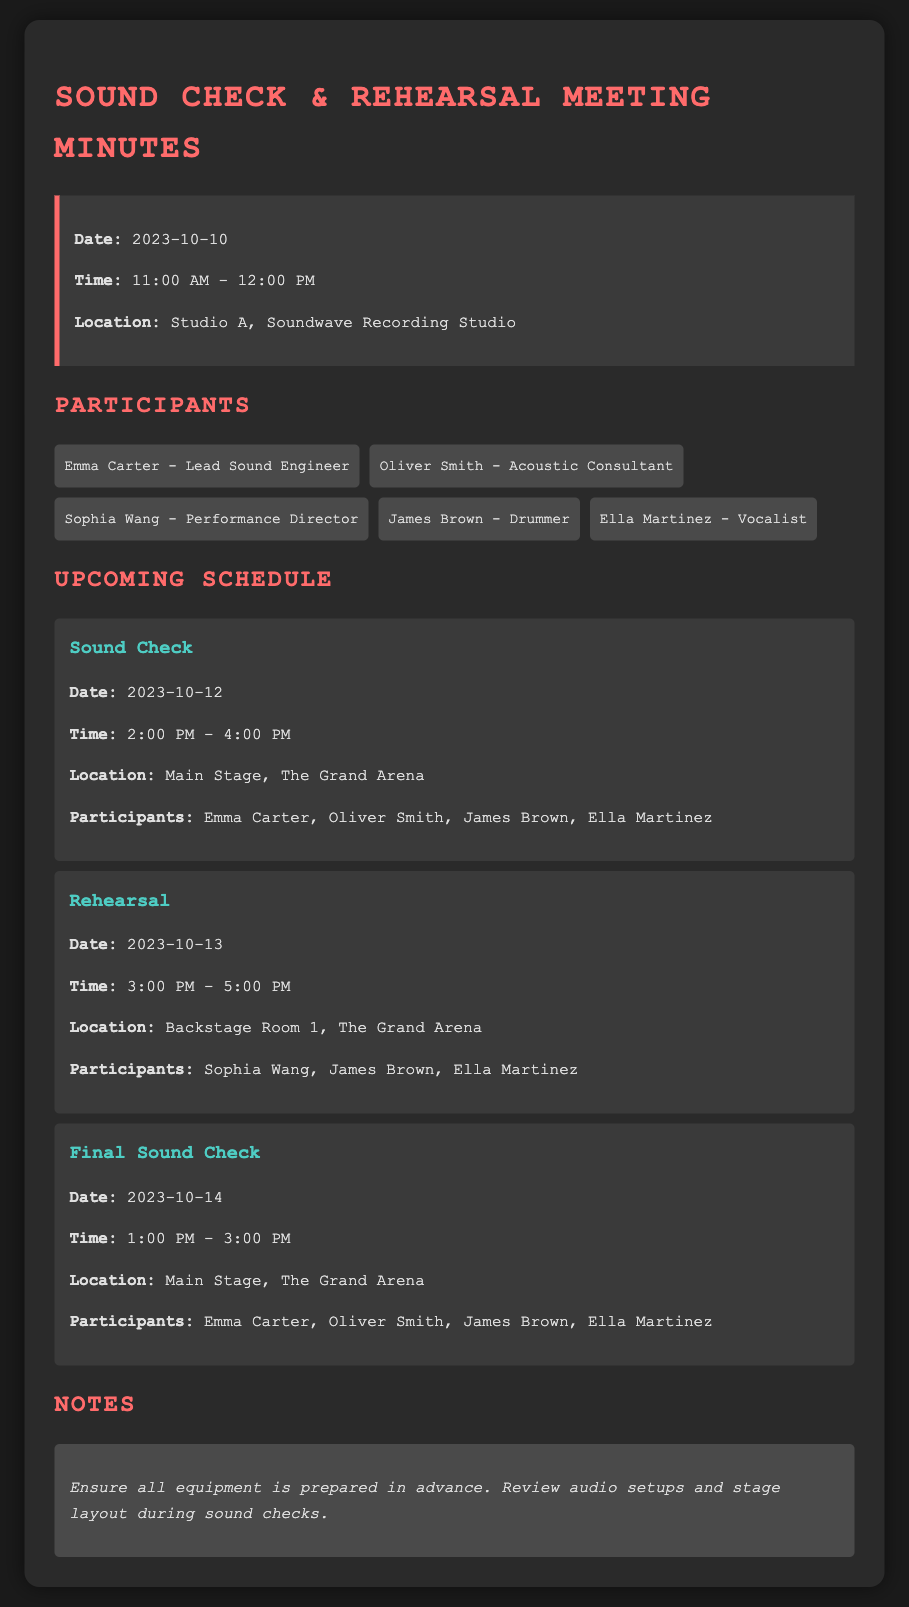what is the date of the next sound check? The next sound check is scheduled for 2023-10-12.
Answer: 2023-10-12 what time is the rehearsal on October 13? The rehearsal on October 13 is from 3:00 PM to 5:00 PM.
Answer: 3:00 PM - 5:00 PM who is participating in the final sound check? The participants in the final sound check are Emma Carter, Oliver Smith, James Brown, and Ella Martinez.
Answer: Emma Carter, Oliver Smith, James Brown, Ella Martinez where is the rehearsal taking place? The rehearsal is taking place in Backstage Room 1, The Grand Arena.
Answer: Backstage Room 1, The Grand Arena what is the purpose of the notes section? The notes section outlines preparatory actions for the sound checks.
Answer: Ensure all equipment is prepared in advance how many participants are listed in total? There are five participants listed in total for the events.
Answer: five what is the location of the sound checks? The sound checks are located at Main Stage, The Grand Arena.
Answer: Main Stage, The Grand Arena who is the performance director? The performance director is Sophia Wang.
Answer: Sophia Wang what is the date of the meeting minutes? The date of the meeting minutes is 2023-10-10.
Answer: 2023-10-10 